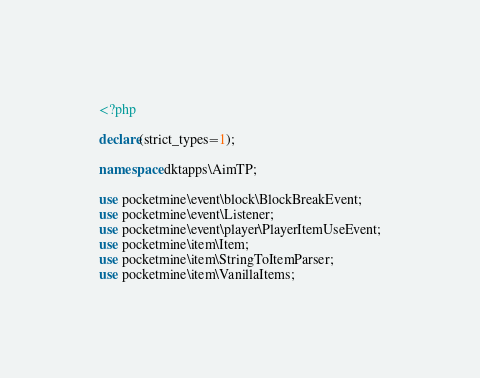Convert code to text. <code><loc_0><loc_0><loc_500><loc_500><_PHP_><?php

declare(strict_types=1);

namespace dktapps\AimTP;

use pocketmine\event\block\BlockBreakEvent;
use pocketmine\event\Listener;
use pocketmine\event\player\PlayerItemUseEvent;
use pocketmine\item\Item;
use pocketmine\item\StringToItemParser;
use pocketmine\item\VanillaItems;</code> 